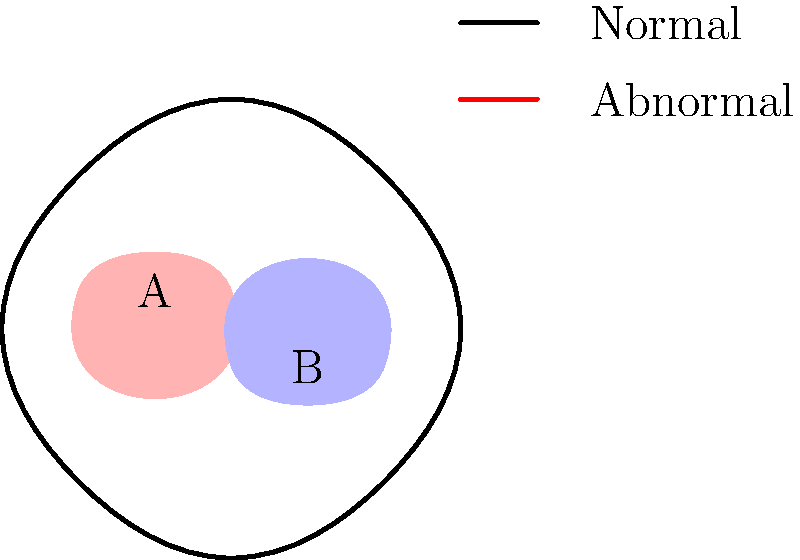In the brain scan image above, two regions (A and B) show different activity levels compared to a typical scan. Which region is more likely to be associated with depression, and why might a machine learning algorithm struggle to accurately diagnose this condition based solely on this image? Step 1: Analyze the image
The brain scan shows two highlighted regions:
- Region A (red): located in the upper frontal area
- Region B (blue): located in the lower posterior area

Step 2: Consider depression-related brain activity
Depression is often associated with abnormal activity in the prefrontal cortex and limbic system, which are primarily located in the frontal and middle areas of the brain.

Step 3: Identify the more likely region
Based on this information, Region A (red) is more likely to be associated with depression due to its location in the frontal area of the brain.

Step 4: Machine learning challenges
A machine learning algorithm might struggle to accurately diagnose depression based solely on this image for several reasons:

a) Limited data: A single brain scan provides insufficient information for a comprehensive diagnosis.

b) Lack of context: The algorithm doesn't have access to patient history, symptoms, or other clinical data essential for accurate diagnosis.

c) Variability: Brain activity patterns can vary among individuals and may not always conform to typical depression-related patterns.

d) Comorbidity: Depression often co-occurs with other mental health conditions, making it difficult to isolate depression-specific patterns.

e) Oversimplification: Relying on a single image oversimplifies the complex nature of mental health conditions.

f) Lack of temporal information: Depression involves long-term changes in brain function, which cannot be captured in a single static image.

Step 5: Importance of holistic approach
To improve accuracy, machine learning algorithms should incorporate multiple data sources, including longitudinal brain scans, clinical assessments, and patient history, rather than relying solely on a single image.
Answer: Region A; limited data and lack of context 